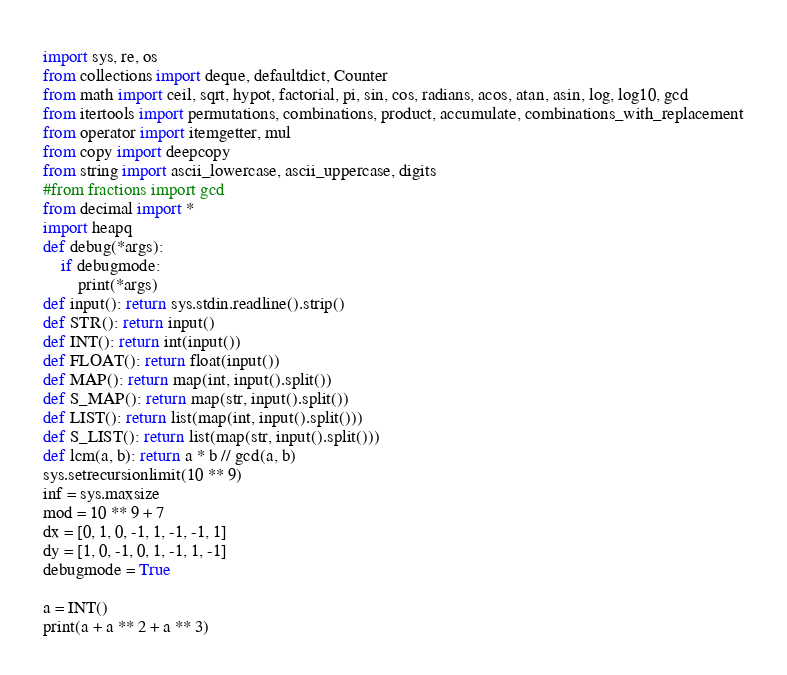Convert code to text. <code><loc_0><loc_0><loc_500><loc_500><_Python_>import sys, re, os
from collections import deque, defaultdict, Counter
from math import ceil, sqrt, hypot, factorial, pi, sin, cos, radians, acos, atan, asin, log, log10, gcd
from itertools import permutations, combinations, product, accumulate, combinations_with_replacement
from operator import itemgetter, mul
from copy import deepcopy
from string import ascii_lowercase, ascii_uppercase, digits
#from fractions import gcd
from decimal import *
import heapq
def debug(*args):
    if debugmode:
        print(*args)
def input(): return sys.stdin.readline().strip()
def STR(): return input()
def INT(): return int(input())
def FLOAT(): return float(input())
def MAP(): return map(int, input().split())
def S_MAP(): return map(str, input().split())
def LIST(): return list(map(int, input().split()))
def S_LIST(): return list(map(str, input().split()))
def lcm(a, b): return a * b // gcd(a, b)
sys.setrecursionlimit(10 ** 9)
inf = sys.maxsize
mod = 10 ** 9 + 7
dx = [0, 1, 0, -1, 1, -1, -1, 1]
dy = [1, 0, -1, 0, 1, -1, 1, -1]
debugmode = True

a = INT()
print(a + a ** 2 + a ** 3)</code> 